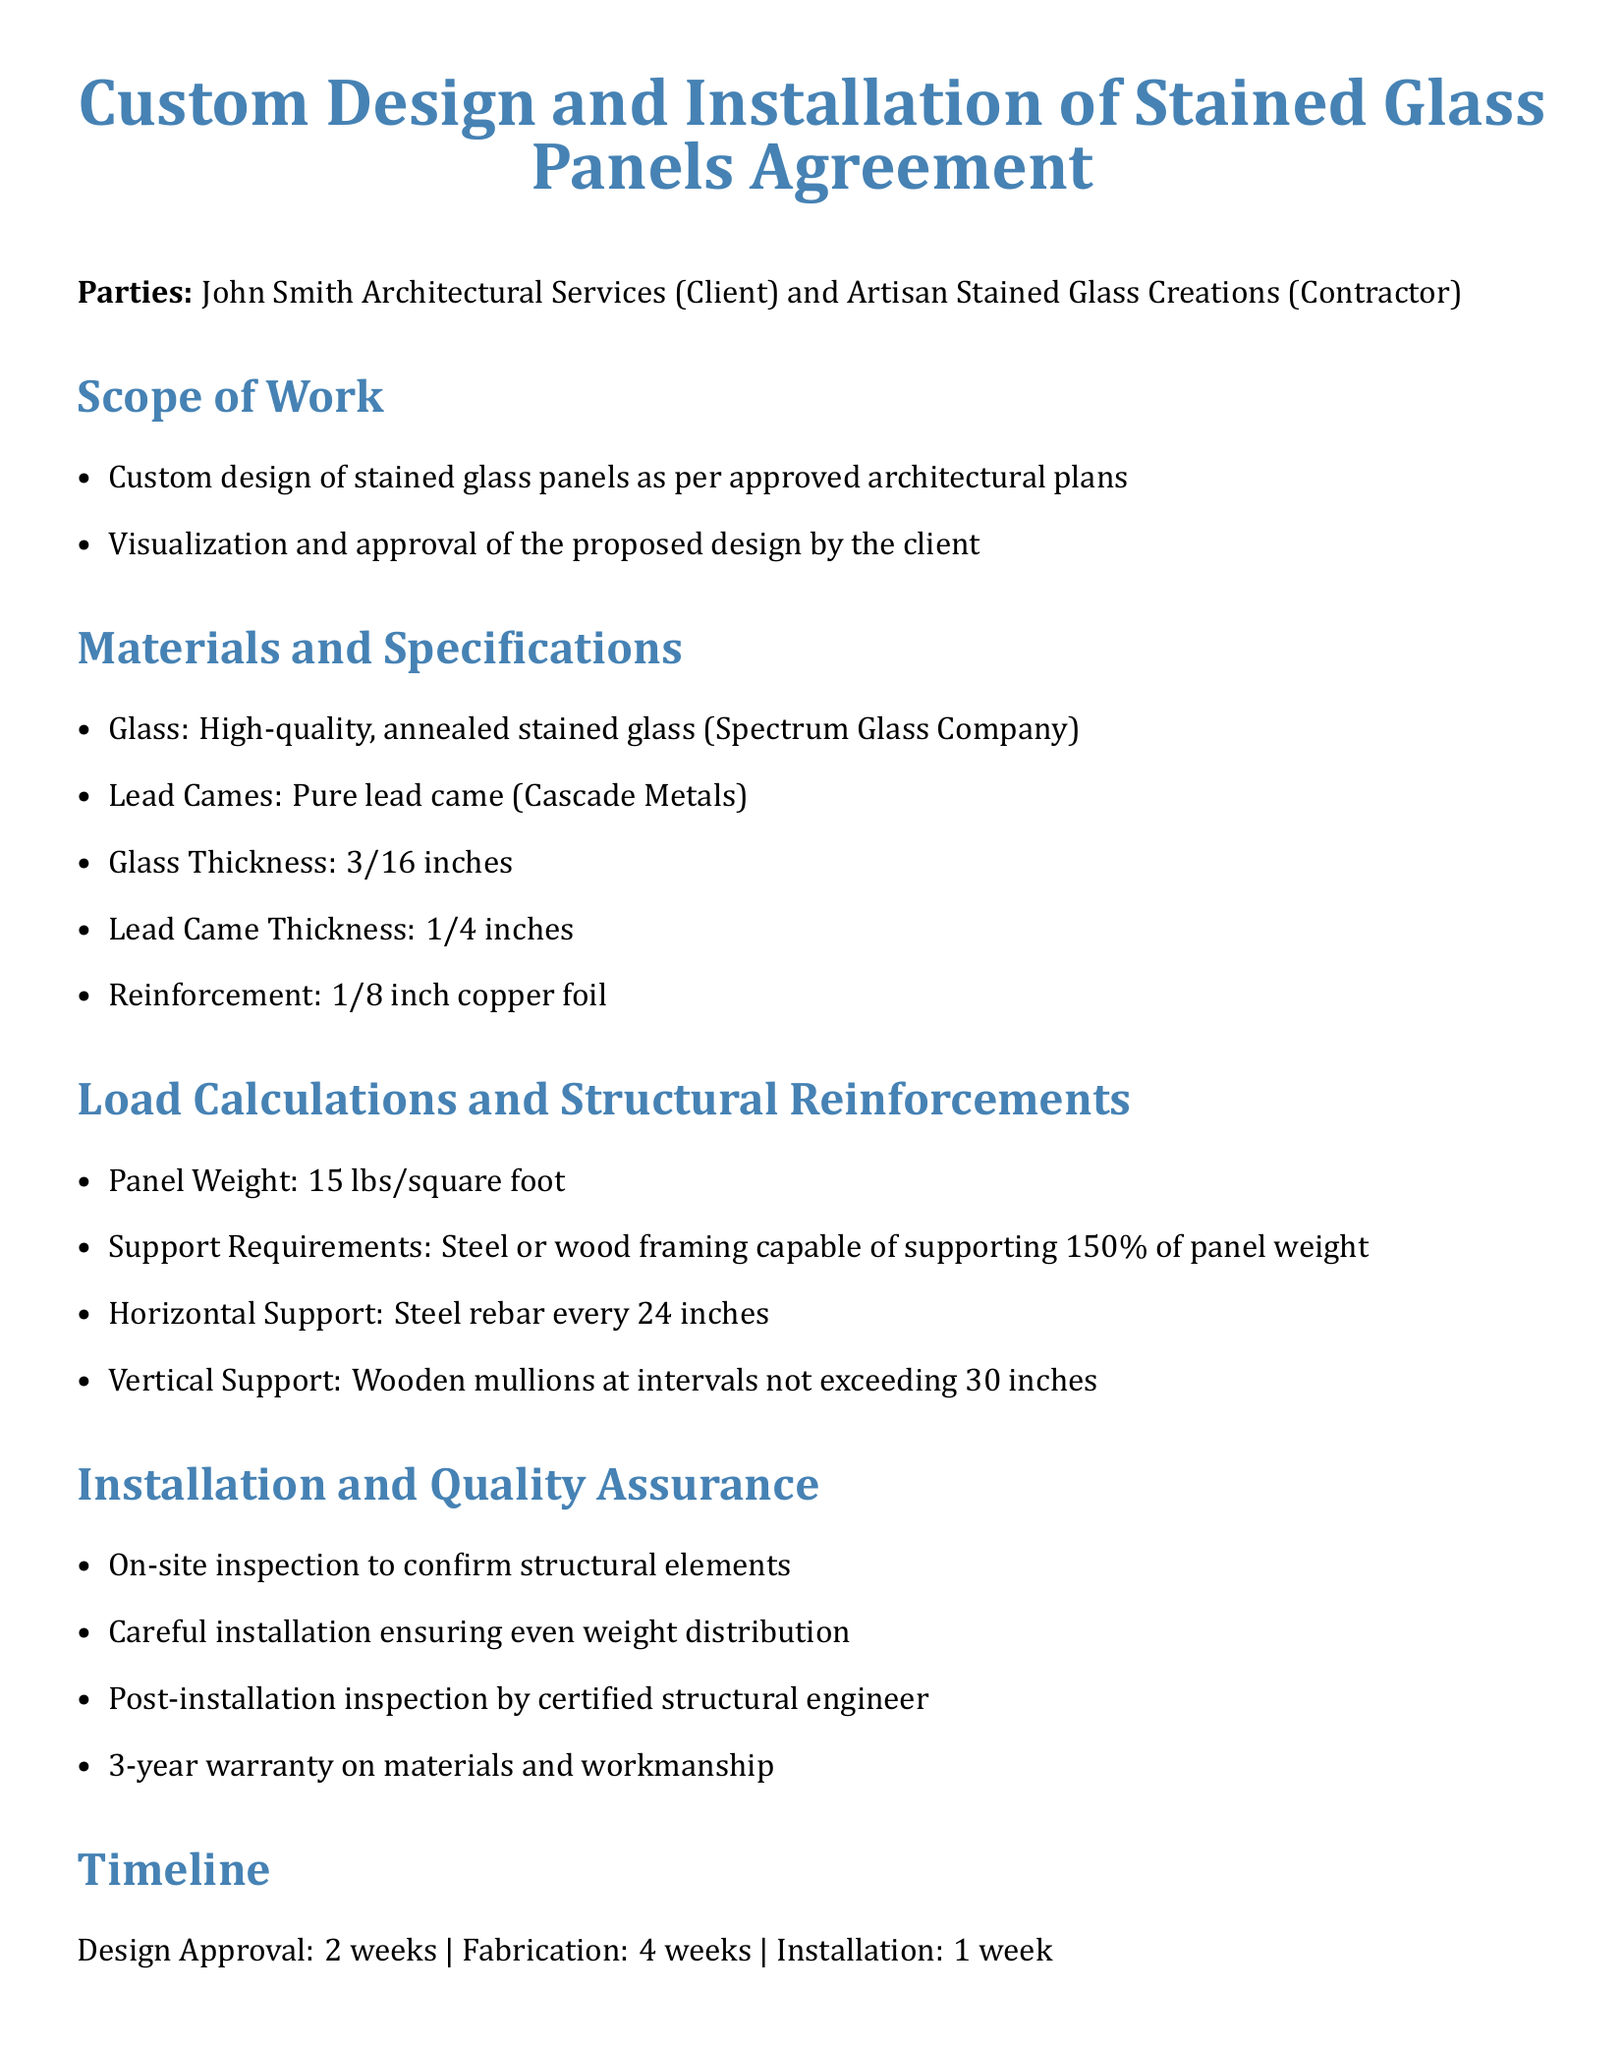What is the name of the contractor? The contractor in the document is identified as Artisan Stained Glass Creations.
Answer: Artisan Stained Glass Creations What is the total amount for the project? The total amount specified in the payment terms section of the document is $50,000.
Answer: $50,000 What is the glass thickness specified? The specified thickness of the glass in the materials section is 3/16 inches.
Answer: 3/16 inches What is the support requirement for the panels? The document states that the support is required to be capable of supporting 150% of the panel weight.
Answer: 150% What is the warranty period on materials and workmanship? According to the installation and quality assurance section, the warranty period is 3 years.
Answer: 3 years What is the timeline for design approval? The document mentions that design approval will take 2 weeks.
Answer: 2 weeks How often should vertical support be installed? The vertical support, as explained in the load calculations section, should not exceed intervals of 30 inches.
Answer: 30 inches What materials are specified for lead came? In the materials and specifications section, the lead came is specified as pure lead came from Cascade Metals.
Answer: pure lead came What is the installation timeline? The installation phase of the project is specified to take 1 week.
Answer: 1 week 